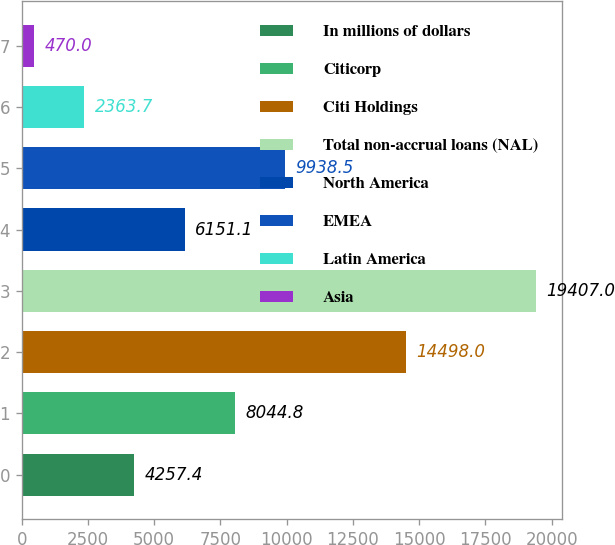Convert chart to OTSL. <chart><loc_0><loc_0><loc_500><loc_500><bar_chart><fcel>In millions of dollars<fcel>Citicorp<fcel>Citi Holdings<fcel>Total non-accrual loans (NAL)<fcel>North America<fcel>EMEA<fcel>Latin America<fcel>Asia<nl><fcel>4257.4<fcel>8044.8<fcel>14498<fcel>19407<fcel>6151.1<fcel>9938.5<fcel>2363.7<fcel>470<nl></chart> 